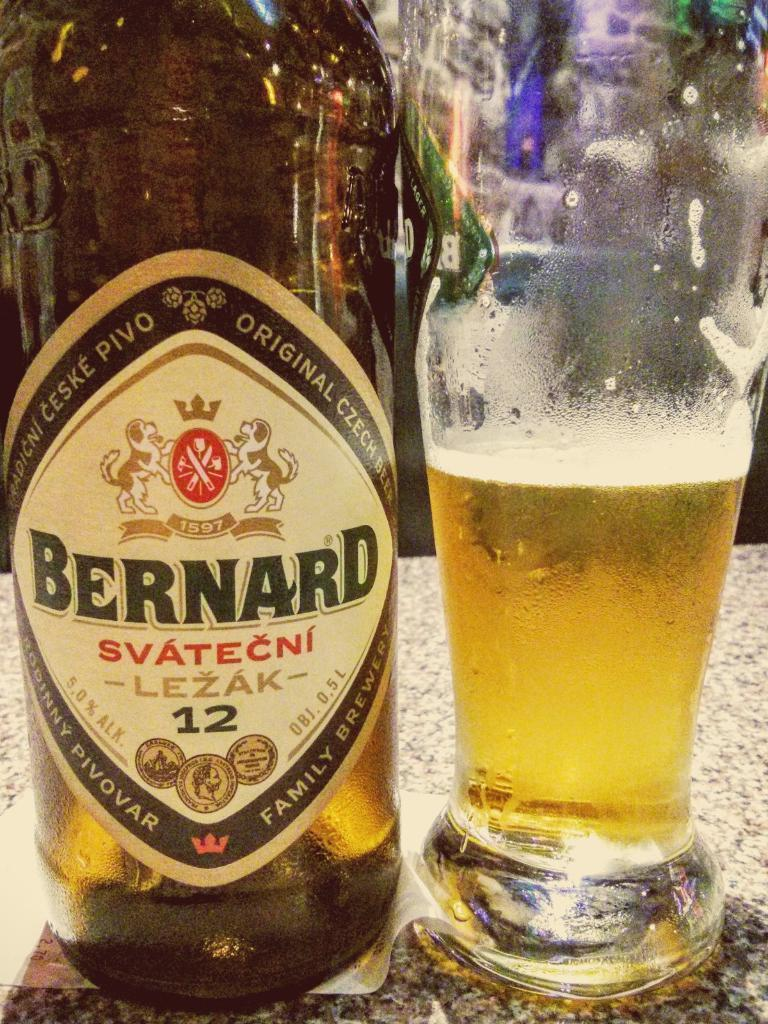What is on the table in the image? There is a bottle and a glass on the table in the image. What is the glass filled with? The glass is filled with liquid. Is there any additional information about the bottle? Yes, there is a sticker on the bottle. What type of ink is being used to write on the ice in the image? There is no ink or ice present in the image; it only features a bottle and a glass on a table. 